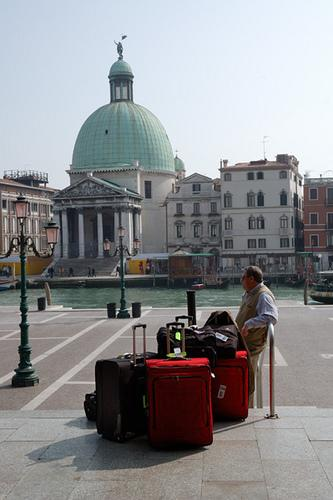What is this man enjoying here? weather 